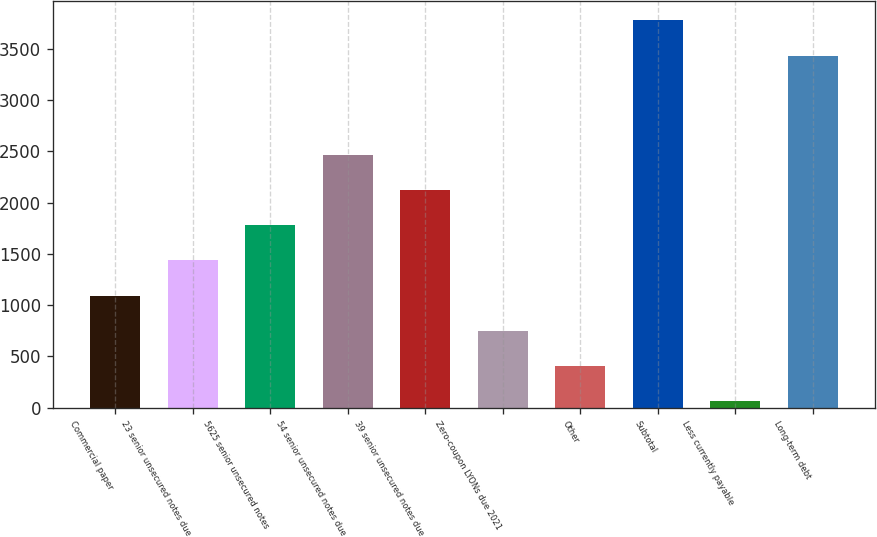<chart> <loc_0><loc_0><loc_500><loc_500><bar_chart><fcel>Commercial paper<fcel>23 senior unsecured notes due<fcel>5625 senior unsecured notes<fcel>54 senior unsecured notes due<fcel>39 senior unsecured notes due<fcel>Zero-coupon LYONs due 2021<fcel>Other<fcel>Subtotal<fcel>Less currently payable<fcel>Long-term debt<nl><fcel>1093.31<fcel>1436.98<fcel>1780.65<fcel>2467.99<fcel>2124.32<fcel>749.64<fcel>405.97<fcel>3780.37<fcel>62.3<fcel>3436.7<nl></chart> 